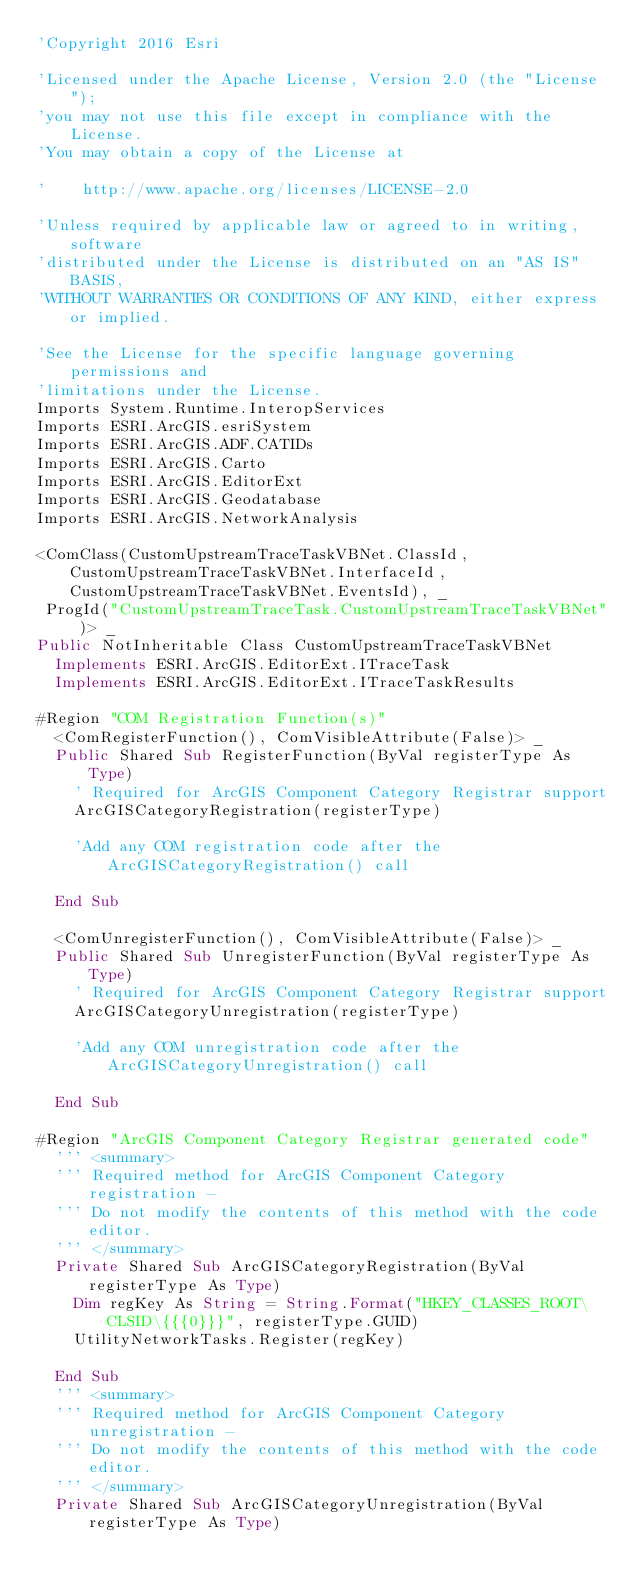<code> <loc_0><loc_0><loc_500><loc_500><_VisualBasic_>'Copyright 2016 Esri

'Licensed under the Apache License, Version 2.0 (the "License");
'you may not use this file except in compliance with the License.
'You may obtain a copy of the License at

'    http://www.apache.org/licenses/LICENSE-2.0

'Unless required by applicable law or agreed to in writing, software
'distributed under the License is distributed on an "AS IS" BASIS,
'WITHOUT WARRANTIES OR CONDITIONS OF ANY KIND, either express or implied.

'See the License for the specific language governing permissions and
'limitations under the License.
Imports System.Runtime.InteropServices
Imports ESRI.ArcGIS.esriSystem
Imports ESRI.ArcGIS.ADF.CATIDs
Imports ESRI.ArcGIS.Carto
Imports ESRI.ArcGIS.EditorExt
Imports ESRI.ArcGIS.Geodatabase
Imports ESRI.ArcGIS.NetworkAnalysis

<ComClass(CustomUpstreamTraceTaskVBNet.ClassId, CustomUpstreamTraceTaskVBNet.InterfaceId, CustomUpstreamTraceTaskVBNet.EventsId), _
 ProgId("CustomUpstreamTraceTask.CustomUpstreamTraceTaskVBNet")> _
Public NotInheritable Class CustomUpstreamTraceTaskVBNet
	Implements ESRI.ArcGIS.EditorExt.ITraceTask
	Implements ESRI.ArcGIS.EditorExt.ITraceTaskResults

#Region "COM Registration Function(s)"
	<ComRegisterFunction(), ComVisibleAttribute(False)> _
	Public Shared Sub RegisterFunction(ByVal registerType As Type)
		' Required for ArcGIS Component Category Registrar support
		ArcGISCategoryRegistration(registerType)

		'Add any COM registration code after the ArcGISCategoryRegistration() call

	End Sub

	<ComUnregisterFunction(), ComVisibleAttribute(False)> _
	Public Shared Sub UnregisterFunction(ByVal registerType As Type)
		' Required for ArcGIS Component Category Registrar support
		ArcGISCategoryUnregistration(registerType)

		'Add any COM unregistration code after the ArcGISCategoryUnregistration() call

	End Sub

#Region "ArcGIS Component Category Registrar generated code"
	''' <summary>
	''' Required method for ArcGIS Component Category registration -
	''' Do not modify the contents of this method with the code editor.
	''' </summary>
	Private Shared Sub ArcGISCategoryRegistration(ByVal registerType As Type)
		Dim regKey As String = String.Format("HKEY_CLASSES_ROOT\CLSID\{{{0}}}", registerType.GUID)
		UtilityNetworkTasks.Register(regKey)

	End Sub
	''' <summary>
	''' Required method for ArcGIS Component Category unregistration -
	''' Do not modify the contents of this method with the code editor.
	''' </summary>
	Private Shared Sub ArcGISCategoryUnregistration(ByVal registerType As Type)</code> 